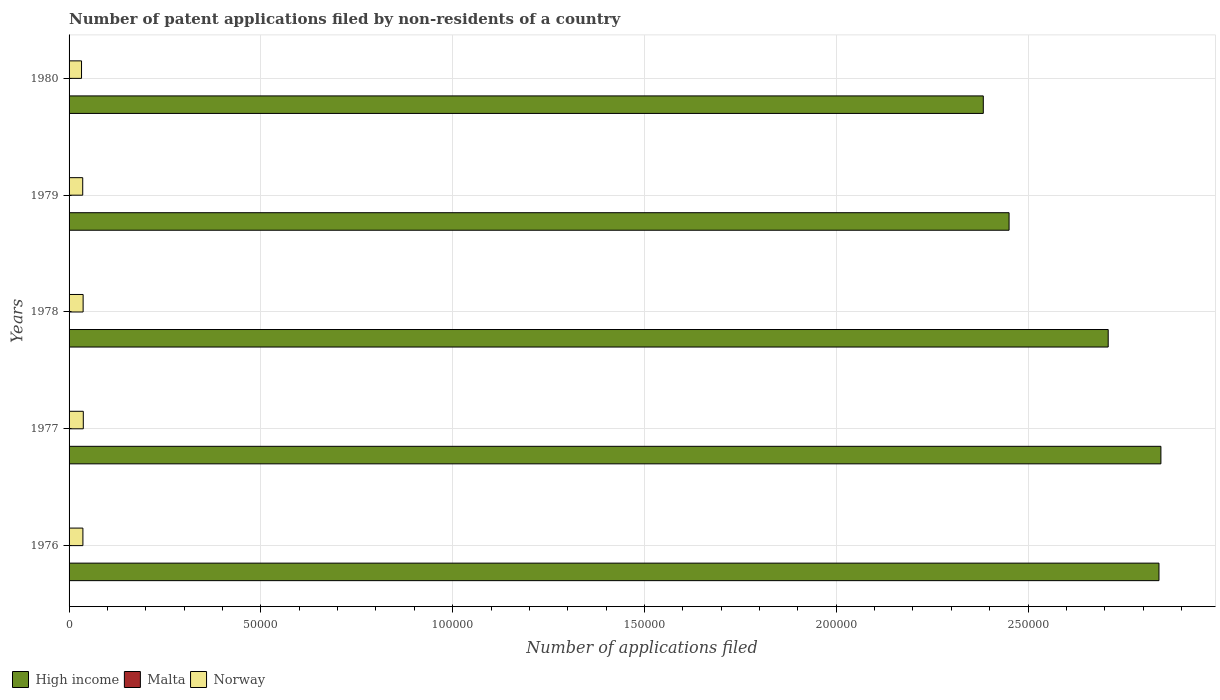How many different coloured bars are there?
Your answer should be compact. 3. How many groups of bars are there?
Keep it short and to the point. 5. Are the number of bars per tick equal to the number of legend labels?
Ensure brevity in your answer.  Yes. Are the number of bars on each tick of the Y-axis equal?
Ensure brevity in your answer.  Yes. How many bars are there on the 3rd tick from the top?
Offer a terse response. 3. What is the label of the 2nd group of bars from the top?
Ensure brevity in your answer.  1979. What is the number of applications filed in High income in 1978?
Provide a short and direct response. 2.71e+05. Across all years, what is the minimum number of applications filed in Norway?
Your answer should be compact. 3247. In which year was the number of applications filed in Malta maximum?
Make the answer very short. 1979. In which year was the number of applications filed in Norway minimum?
Your response must be concise. 1980. What is the difference between the number of applications filed in Norway in 1977 and that in 1978?
Offer a very short reply. 45. What is the difference between the number of applications filed in Norway in 1980 and the number of applications filed in Malta in 1977?
Your answer should be very brief. 3235. What is the average number of applications filed in Malta per year?
Keep it short and to the point. 14. In the year 1978, what is the difference between the number of applications filed in Norway and number of applications filed in Malta?
Give a very brief answer. 3654. What is the ratio of the number of applications filed in Malta in 1976 to that in 1977?
Your answer should be compact. 1.08. Is the difference between the number of applications filed in Norway in 1977 and 1980 greater than the difference between the number of applications filed in Malta in 1977 and 1980?
Your response must be concise. Yes. What is the difference between the highest and the second highest number of applications filed in High income?
Your response must be concise. 505. In how many years, is the number of applications filed in Norway greater than the average number of applications filed in Norway taken over all years?
Your response must be concise. 4. What does the 2nd bar from the top in 1978 represents?
Provide a short and direct response. Malta. What does the 1st bar from the bottom in 1977 represents?
Offer a terse response. High income. Are all the bars in the graph horizontal?
Ensure brevity in your answer.  Yes. What is the difference between two consecutive major ticks on the X-axis?
Give a very brief answer. 5.00e+04. Does the graph contain any zero values?
Offer a very short reply. No. Where does the legend appear in the graph?
Offer a terse response. Bottom left. How are the legend labels stacked?
Keep it short and to the point. Horizontal. What is the title of the graph?
Offer a terse response. Number of patent applications filed by non-residents of a country. Does "St. Lucia" appear as one of the legend labels in the graph?
Keep it short and to the point. No. What is the label or title of the X-axis?
Provide a short and direct response. Number of applications filed. What is the Number of applications filed in High income in 1976?
Offer a very short reply. 2.84e+05. What is the Number of applications filed of Norway in 1976?
Offer a very short reply. 3605. What is the Number of applications filed in High income in 1977?
Your answer should be compact. 2.85e+05. What is the Number of applications filed in Malta in 1977?
Your answer should be very brief. 12. What is the Number of applications filed of Norway in 1977?
Give a very brief answer. 3710. What is the Number of applications filed of High income in 1978?
Your answer should be compact. 2.71e+05. What is the Number of applications filed of Norway in 1978?
Give a very brief answer. 3665. What is the Number of applications filed of High income in 1979?
Keep it short and to the point. 2.45e+05. What is the Number of applications filed in Norway in 1979?
Provide a short and direct response. 3557. What is the Number of applications filed in High income in 1980?
Offer a very short reply. 2.38e+05. What is the Number of applications filed of Malta in 1980?
Provide a succinct answer. 17. What is the Number of applications filed in Norway in 1980?
Your answer should be very brief. 3247. Across all years, what is the maximum Number of applications filed in High income?
Your response must be concise. 2.85e+05. Across all years, what is the maximum Number of applications filed of Norway?
Keep it short and to the point. 3710. Across all years, what is the minimum Number of applications filed of High income?
Offer a terse response. 2.38e+05. Across all years, what is the minimum Number of applications filed in Malta?
Ensure brevity in your answer.  11. Across all years, what is the minimum Number of applications filed of Norway?
Ensure brevity in your answer.  3247. What is the total Number of applications filed of High income in the graph?
Offer a very short reply. 1.32e+06. What is the total Number of applications filed of Norway in the graph?
Your response must be concise. 1.78e+04. What is the difference between the Number of applications filed in High income in 1976 and that in 1977?
Your response must be concise. -505. What is the difference between the Number of applications filed of Norway in 1976 and that in 1977?
Your answer should be very brief. -105. What is the difference between the Number of applications filed in High income in 1976 and that in 1978?
Keep it short and to the point. 1.32e+04. What is the difference between the Number of applications filed of Malta in 1976 and that in 1978?
Provide a short and direct response. 2. What is the difference between the Number of applications filed of Norway in 1976 and that in 1978?
Give a very brief answer. -60. What is the difference between the Number of applications filed of High income in 1976 and that in 1979?
Give a very brief answer. 3.91e+04. What is the difference between the Number of applications filed of Malta in 1976 and that in 1979?
Offer a terse response. -4. What is the difference between the Number of applications filed of Norway in 1976 and that in 1979?
Provide a short and direct response. 48. What is the difference between the Number of applications filed of High income in 1976 and that in 1980?
Provide a short and direct response. 4.58e+04. What is the difference between the Number of applications filed of Malta in 1976 and that in 1980?
Make the answer very short. -4. What is the difference between the Number of applications filed in Norway in 1976 and that in 1980?
Ensure brevity in your answer.  358. What is the difference between the Number of applications filed in High income in 1977 and that in 1978?
Your answer should be very brief. 1.37e+04. What is the difference between the Number of applications filed of Norway in 1977 and that in 1978?
Make the answer very short. 45. What is the difference between the Number of applications filed in High income in 1977 and that in 1979?
Keep it short and to the point. 3.96e+04. What is the difference between the Number of applications filed in Malta in 1977 and that in 1979?
Provide a short and direct response. -5. What is the difference between the Number of applications filed in Norway in 1977 and that in 1979?
Your answer should be very brief. 153. What is the difference between the Number of applications filed in High income in 1977 and that in 1980?
Provide a succinct answer. 4.63e+04. What is the difference between the Number of applications filed of Norway in 1977 and that in 1980?
Make the answer very short. 463. What is the difference between the Number of applications filed in High income in 1978 and that in 1979?
Give a very brief answer. 2.58e+04. What is the difference between the Number of applications filed of Norway in 1978 and that in 1979?
Keep it short and to the point. 108. What is the difference between the Number of applications filed of High income in 1978 and that in 1980?
Give a very brief answer. 3.26e+04. What is the difference between the Number of applications filed of Norway in 1978 and that in 1980?
Offer a very short reply. 418. What is the difference between the Number of applications filed in High income in 1979 and that in 1980?
Your answer should be very brief. 6721. What is the difference between the Number of applications filed in Norway in 1979 and that in 1980?
Give a very brief answer. 310. What is the difference between the Number of applications filed of High income in 1976 and the Number of applications filed of Malta in 1977?
Offer a very short reply. 2.84e+05. What is the difference between the Number of applications filed in High income in 1976 and the Number of applications filed in Norway in 1977?
Make the answer very short. 2.80e+05. What is the difference between the Number of applications filed of Malta in 1976 and the Number of applications filed of Norway in 1977?
Keep it short and to the point. -3697. What is the difference between the Number of applications filed of High income in 1976 and the Number of applications filed of Malta in 1978?
Make the answer very short. 2.84e+05. What is the difference between the Number of applications filed in High income in 1976 and the Number of applications filed in Norway in 1978?
Ensure brevity in your answer.  2.80e+05. What is the difference between the Number of applications filed in Malta in 1976 and the Number of applications filed in Norway in 1978?
Ensure brevity in your answer.  -3652. What is the difference between the Number of applications filed of High income in 1976 and the Number of applications filed of Malta in 1979?
Provide a succinct answer. 2.84e+05. What is the difference between the Number of applications filed of High income in 1976 and the Number of applications filed of Norway in 1979?
Your answer should be very brief. 2.81e+05. What is the difference between the Number of applications filed in Malta in 1976 and the Number of applications filed in Norway in 1979?
Keep it short and to the point. -3544. What is the difference between the Number of applications filed in High income in 1976 and the Number of applications filed in Malta in 1980?
Ensure brevity in your answer.  2.84e+05. What is the difference between the Number of applications filed in High income in 1976 and the Number of applications filed in Norway in 1980?
Keep it short and to the point. 2.81e+05. What is the difference between the Number of applications filed in Malta in 1976 and the Number of applications filed in Norway in 1980?
Your answer should be very brief. -3234. What is the difference between the Number of applications filed of High income in 1977 and the Number of applications filed of Malta in 1978?
Make the answer very short. 2.85e+05. What is the difference between the Number of applications filed of High income in 1977 and the Number of applications filed of Norway in 1978?
Keep it short and to the point. 2.81e+05. What is the difference between the Number of applications filed in Malta in 1977 and the Number of applications filed in Norway in 1978?
Offer a terse response. -3653. What is the difference between the Number of applications filed in High income in 1977 and the Number of applications filed in Malta in 1979?
Your answer should be compact. 2.85e+05. What is the difference between the Number of applications filed of High income in 1977 and the Number of applications filed of Norway in 1979?
Provide a short and direct response. 2.81e+05. What is the difference between the Number of applications filed of Malta in 1977 and the Number of applications filed of Norway in 1979?
Offer a very short reply. -3545. What is the difference between the Number of applications filed of High income in 1977 and the Number of applications filed of Malta in 1980?
Offer a terse response. 2.85e+05. What is the difference between the Number of applications filed of High income in 1977 and the Number of applications filed of Norway in 1980?
Ensure brevity in your answer.  2.81e+05. What is the difference between the Number of applications filed in Malta in 1977 and the Number of applications filed in Norway in 1980?
Your answer should be very brief. -3235. What is the difference between the Number of applications filed in High income in 1978 and the Number of applications filed in Malta in 1979?
Your answer should be very brief. 2.71e+05. What is the difference between the Number of applications filed of High income in 1978 and the Number of applications filed of Norway in 1979?
Your response must be concise. 2.67e+05. What is the difference between the Number of applications filed of Malta in 1978 and the Number of applications filed of Norway in 1979?
Ensure brevity in your answer.  -3546. What is the difference between the Number of applications filed of High income in 1978 and the Number of applications filed of Malta in 1980?
Make the answer very short. 2.71e+05. What is the difference between the Number of applications filed in High income in 1978 and the Number of applications filed in Norway in 1980?
Your answer should be very brief. 2.68e+05. What is the difference between the Number of applications filed of Malta in 1978 and the Number of applications filed of Norway in 1980?
Ensure brevity in your answer.  -3236. What is the difference between the Number of applications filed in High income in 1979 and the Number of applications filed in Malta in 1980?
Your answer should be compact. 2.45e+05. What is the difference between the Number of applications filed in High income in 1979 and the Number of applications filed in Norway in 1980?
Keep it short and to the point. 2.42e+05. What is the difference between the Number of applications filed of Malta in 1979 and the Number of applications filed of Norway in 1980?
Offer a terse response. -3230. What is the average Number of applications filed in High income per year?
Provide a succinct answer. 2.65e+05. What is the average Number of applications filed in Malta per year?
Make the answer very short. 14. What is the average Number of applications filed of Norway per year?
Provide a succinct answer. 3556.8. In the year 1976, what is the difference between the Number of applications filed in High income and Number of applications filed in Malta?
Make the answer very short. 2.84e+05. In the year 1976, what is the difference between the Number of applications filed of High income and Number of applications filed of Norway?
Your answer should be compact. 2.81e+05. In the year 1976, what is the difference between the Number of applications filed in Malta and Number of applications filed in Norway?
Offer a very short reply. -3592. In the year 1977, what is the difference between the Number of applications filed of High income and Number of applications filed of Malta?
Your response must be concise. 2.85e+05. In the year 1977, what is the difference between the Number of applications filed of High income and Number of applications filed of Norway?
Your answer should be very brief. 2.81e+05. In the year 1977, what is the difference between the Number of applications filed in Malta and Number of applications filed in Norway?
Your response must be concise. -3698. In the year 1978, what is the difference between the Number of applications filed of High income and Number of applications filed of Malta?
Your answer should be very brief. 2.71e+05. In the year 1978, what is the difference between the Number of applications filed in High income and Number of applications filed in Norway?
Give a very brief answer. 2.67e+05. In the year 1978, what is the difference between the Number of applications filed of Malta and Number of applications filed of Norway?
Your answer should be very brief. -3654. In the year 1979, what is the difference between the Number of applications filed in High income and Number of applications filed in Malta?
Offer a very short reply. 2.45e+05. In the year 1979, what is the difference between the Number of applications filed of High income and Number of applications filed of Norway?
Offer a very short reply. 2.42e+05. In the year 1979, what is the difference between the Number of applications filed of Malta and Number of applications filed of Norway?
Make the answer very short. -3540. In the year 1980, what is the difference between the Number of applications filed of High income and Number of applications filed of Malta?
Provide a succinct answer. 2.38e+05. In the year 1980, what is the difference between the Number of applications filed in High income and Number of applications filed in Norway?
Provide a succinct answer. 2.35e+05. In the year 1980, what is the difference between the Number of applications filed of Malta and Number of applications filed of Norway?
Your answer should be very brief. -3230. What is the ratio of the Number of applications filed in High income in 1976 to that in 1977?
Your answer should be compact. 1. What is the ratio of the Number of applications filed of Norway in 1976 to that in 1977?
Offer a very short reply. 0.97. What is the ratio of the Number of applications filed in High income in 1976 to that in 1978?
Your response must be concise. 1.05. What is the ratio of the Number of applications filed of Malta in 1976 to that in 1978?
Give a very brief answer. 1.18. What is the ratio of the Number of applications filed of Norway in 1976 to that in 1978?
Your answer should be compact. 0.98. What is the ratio of the Number of applications filed of High income in 1976 to that in 1979?
Offer a terse response. 1.16. What is the ratio of the Number of applications filed of Malta in 1976 to that in 1979?
Provide a succinct answer. 0.76. What is the ratio of the Number of applications filed in Norway in 1976 to that in 1979?
Your response must be concise. 1.01. What is the ratio of the Number of applications filed of High income in 1976 to that in 1980?
Your response must be concise. 1.19. What is the ratio of the Number of applications filed of Malta in 1976 to that in 1980?
Give a very brief answer. 0.76. What is the ratio of the Number of applications filed in Norway in 1976 to that in 1980?
Provide a succinct answer. 1.11. What is the ratio of the Number of applications filed in High income in 1977 to that in 1978?
Offer a very short reply. 1.05. What is the ratio of the Number of applications filed of Malta in 1977 to that in 1978?
Keep it short and to the point. 1.09. What is the ratio of the Number of applications filed of Norway in 1977 to that in 1978?
Provide a short and direct response. 1.01. What is the ratio of the Number of applications filed of High income in 1977 to that in 1979?
Keep it short and to the point. 1.16. What is the ratio of the Number of applications filed of Malta in 1977 to that in 1979?
Offer a terse response. 0.71. What is the ratio of the Number of applications filed in Norway in 1977 to that in 1979?
Offer a terse response. 1.04. What is the ratio of the Number of applications filed in High income in 1977 to that in 1980?
Offer a terse response. 1.19. What is the ratio of the Number of applications filed in Malta in 1977 to that in 1980?
Keep it short and to the point. 0.71. What is the ratio of the Number of applications filed of Norway in 1977 to that in 1980?
Your response must be concise. 1.14. What is the ratio of the Number of applications filed in High income in 1978 to that in 1979?
Offer a very short reply. 1.11. What is the ratio of the Number of applications filed in Malta in 1978 to that in 1979?
Give a very brief answer. 0.65. What is the ratio of the Number of applications filed of Norway in 1978 to that in 1979?
Your answer should be compact. 1.03. What is the ratio of the Number of applications filed in High income in 1978 to that in 1980?
Your answer should be compact. 1.14. What is the ratio of the Number of applications filed in Malta in 1978 to that in 1980?
Provide a succinct answer. 0.65. What is the ratio of the Number of applications filed in Norway in 1978 to that in 1980?
Your answer should be compact. 1.13. What is the ratio of the Number of applications filed in High income in 1979 to that in 1980?
Your answer should be compact. 1.03. What is the ratio of the Number of applications filed in Malta in 1979 to that in 1980?
Offer a very short reply. 1. What is the ratio of the Number of applications filed in Norway in 1979 to that in 1980?
Provide a short and direct response. 1.1. What is the difference between the highest and the second highest Number of applications filed in High income?
Keep it short and to the point. 505. What is the difference between the highest and the second highest Number of applications filed of Malta?
Offer a very short reply. 0. What is the difference between the highest and the second highest Number of applications filed of Norway?
Offer a terse response. 45. What is the difference between the highest and the lowest Number of applications filed in High income?
Your answer should be very brief. 4.63e+04. What is the difference between the highest and the lowest Number of applications filed of Malta?
Your answer should be very brief. 6. What is the difference between the highest and the lowest Number of applications filed in Norway?
Offer a very short reply. 463. 